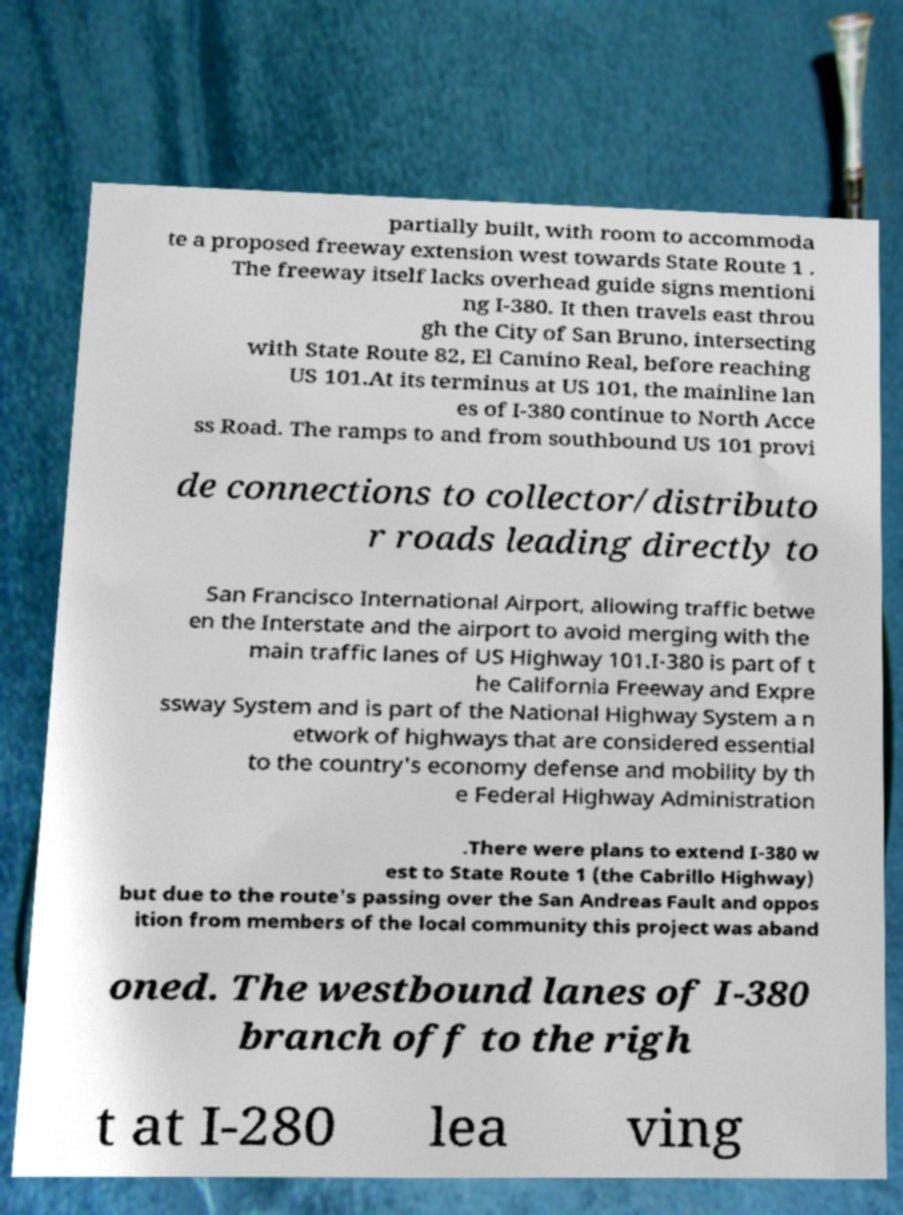Please read and relay the text visible in this image. What does it say? partially built, with room to accommoda te a proposed freeway extension west towards State Route 1 . The freeway itself lacks overhead guide signs mentioni ng I-380. It then travels east throu gh the City of San Bruno, intersecting with State Route 82, El Camino Real, before reaching US 101.At its terminus at US 101, the mainline lan es of I-380 continue to North Acce ss Road. The ramps to and from southbound US 101 provi de connections to collector/distributo r roads leading directly to San Francisco International Airport, allowing traffic betwe en the Interstate and the airport to avoid merging with the main traffic lanes of US Highway 101.I-380 is part of t he California Freeway and Expre ssway System and is part of the National Highway System a n etwork of highways that are considered essential to the country's economy defense and mobility by th e Federal Highway Administration .There were plans to extend I-380 w est to State Route 1 (the Cabrillo Highway) but due to the route's passing over the San Andreas Fault and oppos ition from members of the local community this project was aband oned. The westbound lanes of I-380 branch off to the righ t at I-280 lea ving 